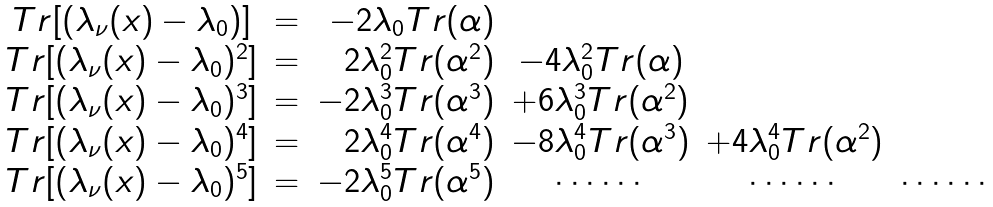<formula> <loc_0><loc_0><loc_500><loc_500>\begin{array} { c c r c c c } T r [ ( \lambda _ { \nu } ( x ) - \lambda _ { 0 } ) ] & = & - 2 \lambda _ { 0 } T r ( \alpha ) & & & \\ T r [ ( \lambda _ { \nu } ( x ) - \lambda _ { 0 } ) ^ { 2 } ] & = & 2 \lambda ^ { 2 } _ { 0 } T r ( \alpha ^ { 2 } ) & - 4 \lambda ^ { 2 } _ { 0 } T r ( \alpha ) & & \\ T r [ ( \lambda _ { \nu } ( x ) - \lambda _ { 0 } ) ^ { 3 } ] & = & - 2 \lambda ^ { 3 } _ { 0 } T r ( \alpha ^ { 3 } ) & + 6 \lambda ^ { 3 } _ { 0 } T r ( \alpha ^ { 2 } ) & & \\ T r [ ( \lambda _ { \nu } ( x ) - \lambda _ { 0 } ) ^ { 4 } ] & = & 2 \lambda ^ { 4 } _ { 0 } T r ( \alpha ^ { 4 } ) & - 8 \lambda ^ { 4 } _ { 0 } T r ( \alpha ^ { 3 } ) & + 4 \lambda ^ { 4 } _ { 0 } T r ( \alpha ^ { 2 } ) & \\ T r [ ( \lambda _ { \nu } ( x ) - \lambda _ { 0 } ) ^ { 5 } ] & = & - 2 \lambda ^ { 5 } _ { 0 } T r ( \alpha ^ { 5 } ) & \cdots \cdots & \cdots \cdots & \cdots \cdots \end{array}</formula> 